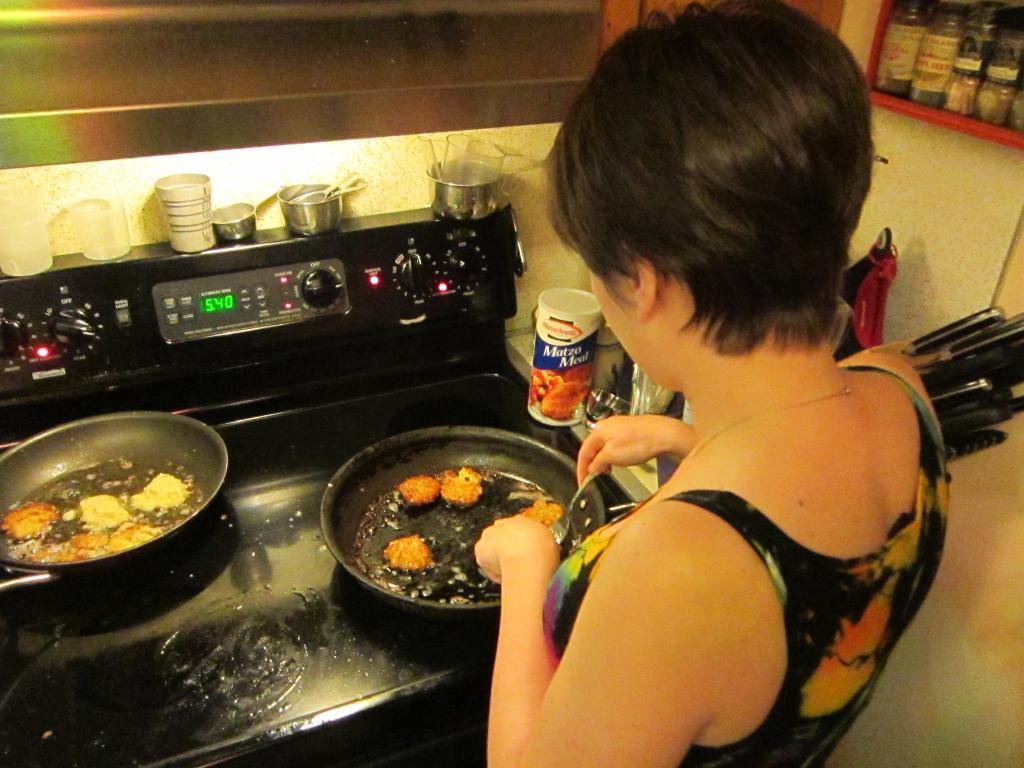Could you give a brief overview of what you see in this image? In this image I can see a person holding a spoon and in front of person I can see a table , on the table I can see bowls and food and micro oven and top of micro oven I can see glasses and bowls beside person I can see bottles and rack , on rack I can see bottles and in the top right and on the right side I can see the wall. 